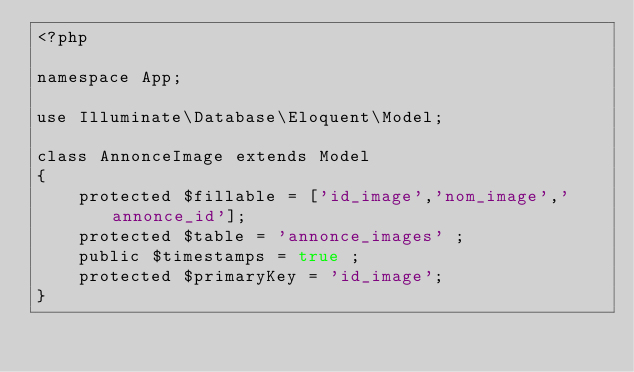Convert code to text. <code><loc_0><loc_0><loc_500><loc_500><_PHP_><?php

namespace App;

use Illuminate\Database\Eloquent\Model;

class AnnonceImage extends Model
{
    protected $fillable = ['id_image','nom_image','annonce_id'];
    protected $table = 'annonce_images' ;
    public $timestamps = true ;
    protected $primaryKey = 'id_image';
}
</code> 